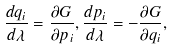<formula> <loc_0><loc_0><loc_500><loc_500>\frac { d q _ { i } } { d \lambda } = \frac { \partial G } { \partial p _ { i } } , \frac { d p _ { i } } { d \lambda } = - \frac { \partial G } { \partial q _ { i } } ,</formula> 